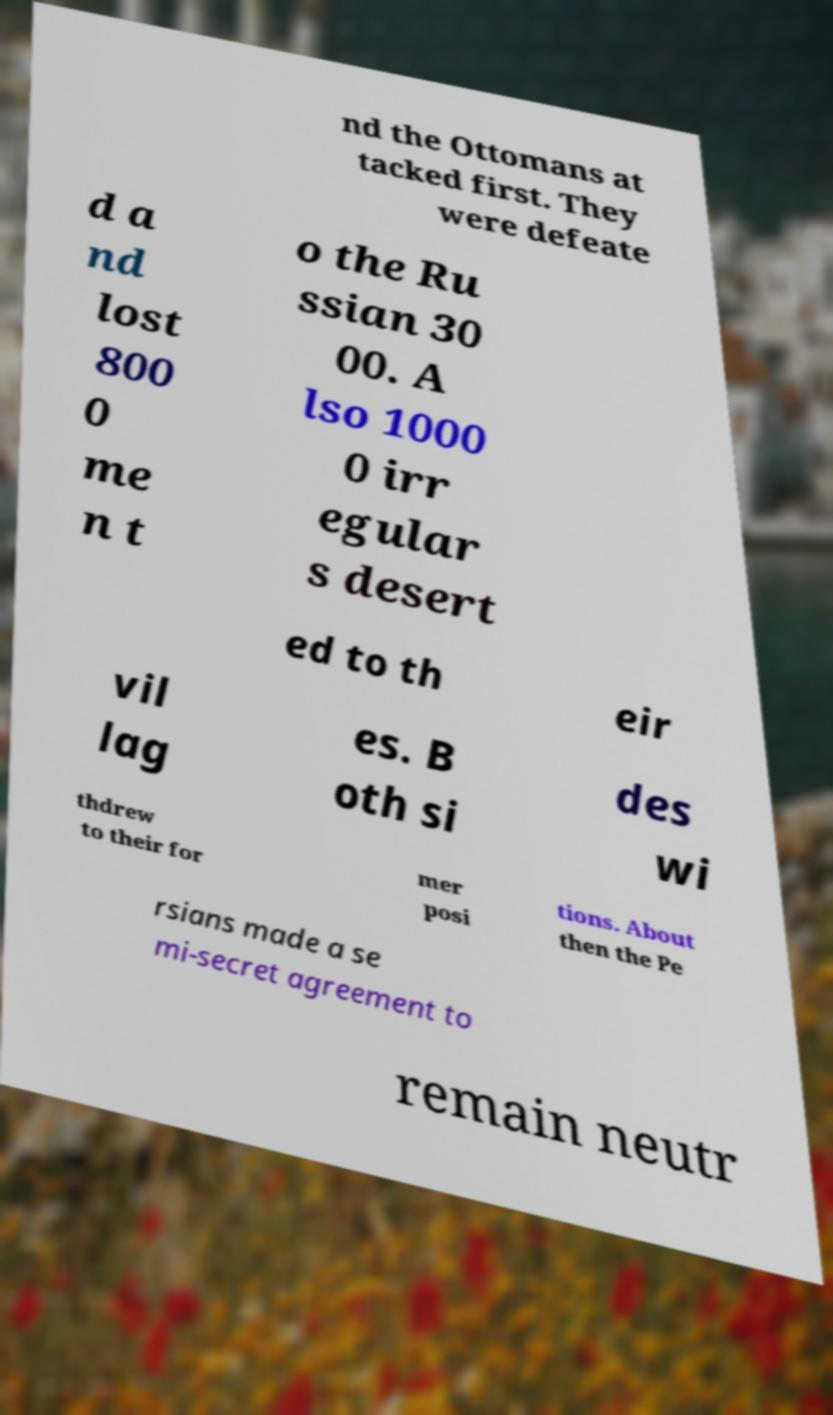Could you assist in decoding the text presented in this image and type it out clearly? nd the Ottomans at tacked first. They were defeate d a nd lost 800 0 me n t o the Ru ssian 30 00. A lso 1000 0 irr egular s desert ed to th eir vil lag es. B oth si des wi thdrew to their for mer posi tions. About then the Pe rsians made a se mi-secret agreement to remain neutr 